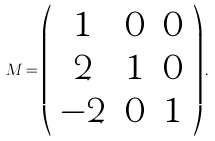<formula> <loc_0><loc_0><loc_500><loc_500>M = \left ( \begin{array} { c c c } 1 & 0 & 0 \\ 2 & 1 & 0 \\ - 2 & 0 & 1 \end{array} \right ) .</formula> 